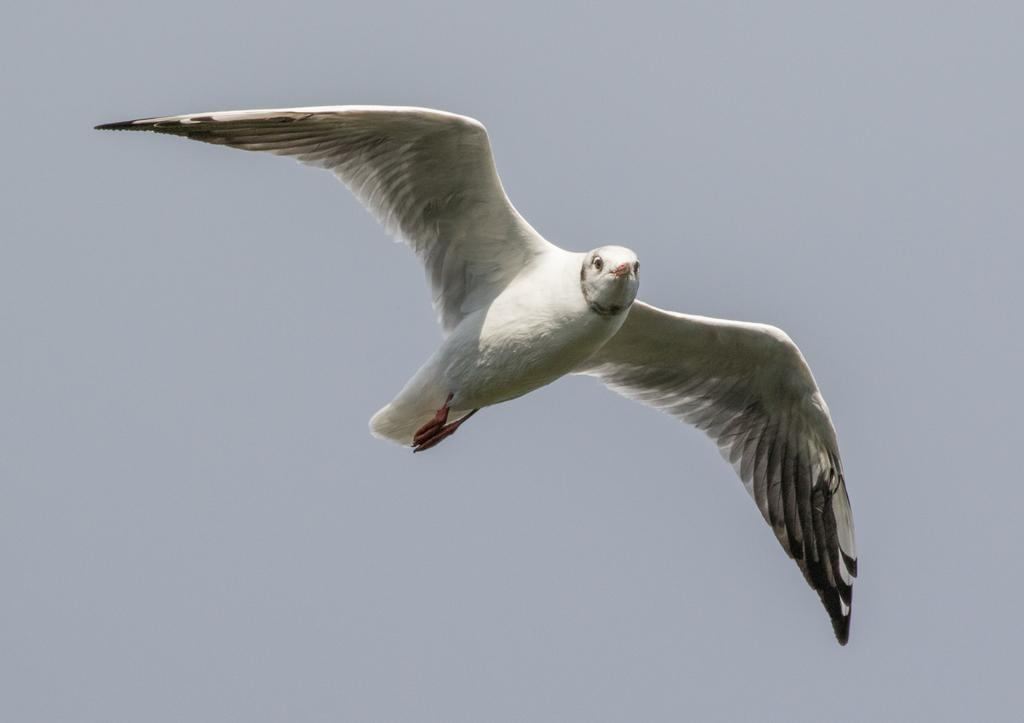What is the main subject of the image? There is a bird in the middle of the image. Can you describe the bird's appearance? The bird is white in color. What can be seen in the background of the image? The sky is visible in the background of the image. What type of rake is the bird using to clear the leaves in the image? There is no rake present in the image, and the bird is not performing any such activity. 